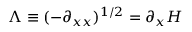Convert formula to latex. <formula><loc_0><loc_0><loc_500><loc_500>\Lambda \equiv ( - \partial _ { x x } ) ^ { 1 / 2 } = \partial _ { x } H</formula> 